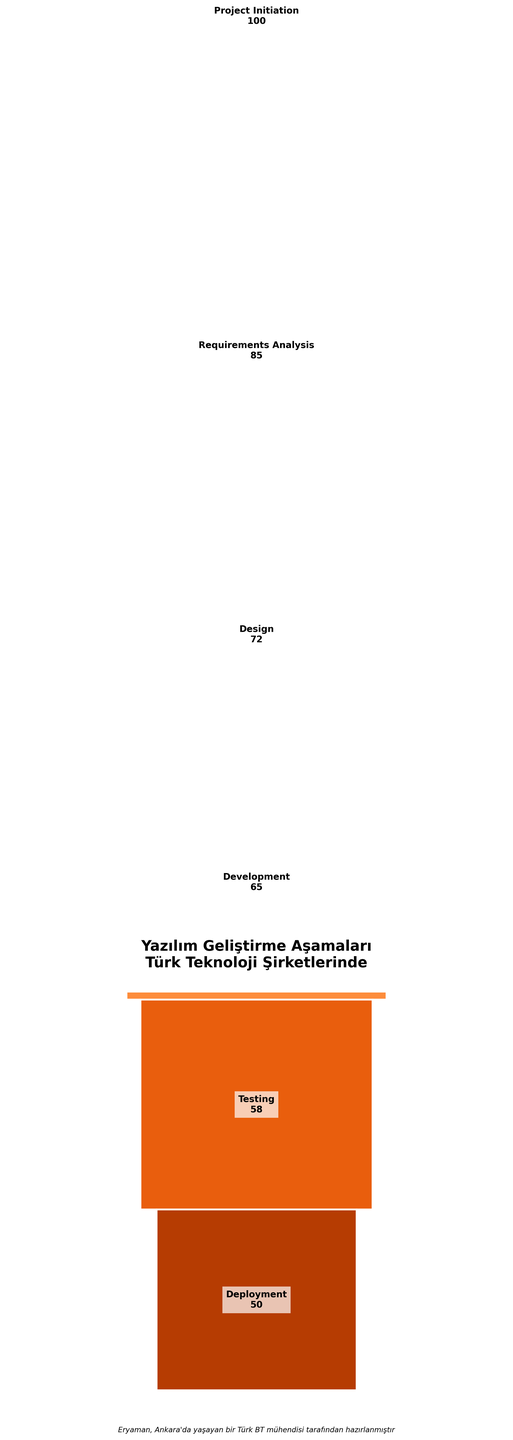What is the title of the funnel chart? The title is located at the top of the figure, typically in a more prominent and larger font size. It summarizes the content of the chart.
Answer: Yazılım Geliştirme Aşamaları Türk Teknoloji Şirketlerinde Hangi aşamada en yüksek proje sayısı ve kaç proje var? En üstte ve en geniş olan aşama, en yüksek proje sayısının olduğu aşamadır. Bu aşama "Project Initiation" ve 100 projeye sahiptir.
Answer: Project Initiation, 100 Görselde kaç farklı aşama var? Görselde her aşama için bir segment vardır ve her segmentin üzerinde aşama adı yazılıdır. Bu isimleri sayarak toplam aşama sayısını bulabiliriz.
Answer: 6 Geliştirme aşamasından test aşamasına kadar kaç proje kaybediliyor? Geliştirme aşamasında 65 proje var ve test aşamasında 58 proje var. Kaybedilen proje sayısını bulmak için 65'ten 58'i çıkarıyoruz.
Answer: 7 Hangi aşamada projelerin çoğunluğu kaybediliyor? Bu soruyu cevaplamak için her aşamada projelerin azalmasının ne kadar olduğunu kontrol etmek gerekiyor. En büyük fark "Project Initiation"dan "Requirements Analysis"a olan farktır ve 100 - 85 = 15 projedir.
Answer: Requirements Analysis Projelerin yüzde kaçı test aşamasını geçip deployment aşamasına ulaşır? Test aşamasında 58 proje var ve deployment aşamasında 50 proje var. Yüzde hesaplamak için (50/58) * 100 işlemi yapılır.
Answer: Yaklaşık %86.2 En dar segment hangi aşamaya ait? En dar segment en az proje sayısına sahip aşama olacak. Grafikte en aşağıda bulunan ve altında en az alan kaplayan segment, yani "Deployment" aşamasıdır.
Answer: Deployment Requirements Analysis aşamasında kaç proje başarıyla tamamlanmamış ve bir sonraki aşamada yer almamış? Requirements Analysis aşamasında 85 proje var, ancak Design aşamasında 72 proje yer alıyor. Kaybedilen projeler 85 - 72 = 13 projedir.
Answer: 13 Aşamalar arasında en büyük projeden en küçük projeye doğru sıralama nedir? En büyükten en küçüğe doğru aşamaları sıralamak için proje sayılarına göre aşamaları sıralamalıyız: Project Initiation (100), Requirements Analysis (85), Design (72), Development (65), Testing (58), Deployment (50).
Answer: Project Initiation, Requirements Analysis, Design, Development, Testing, Deployment 